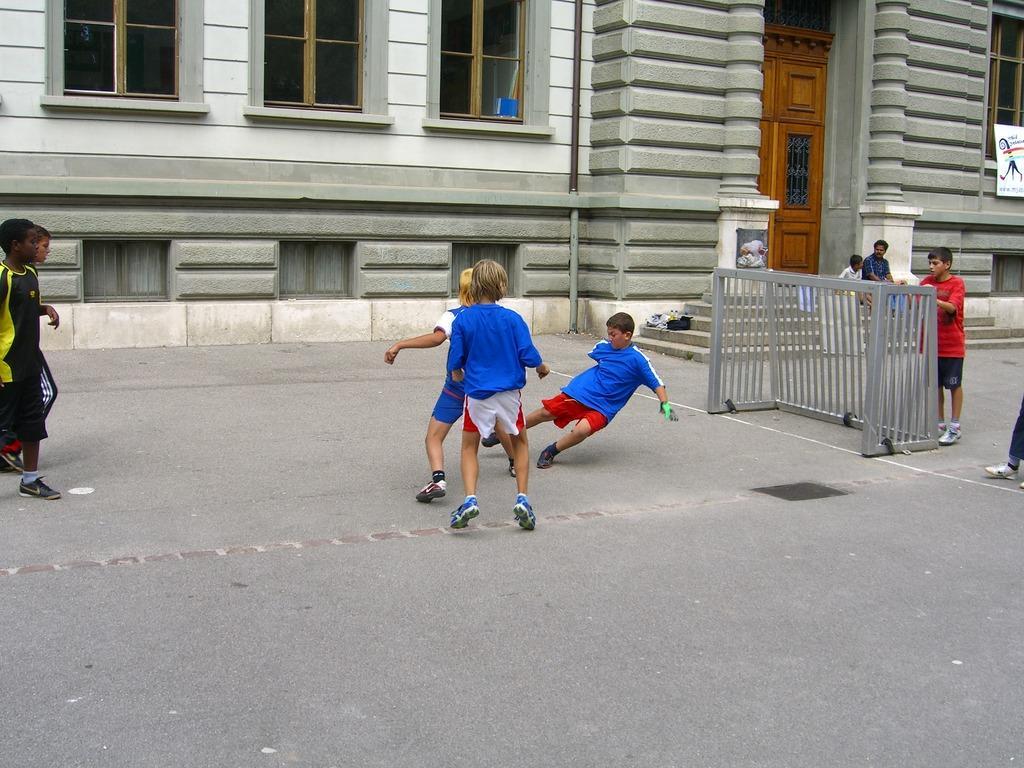How would you summarize this image in a sentence or two? There are groups of people standing. This looks like an iron grill. I can see a building with the windows and a door. There are two people sitting on the stairs. On the right side of the image, that looks like a board, which is attached to a building wall. Here is a pole. I think this is a road. 